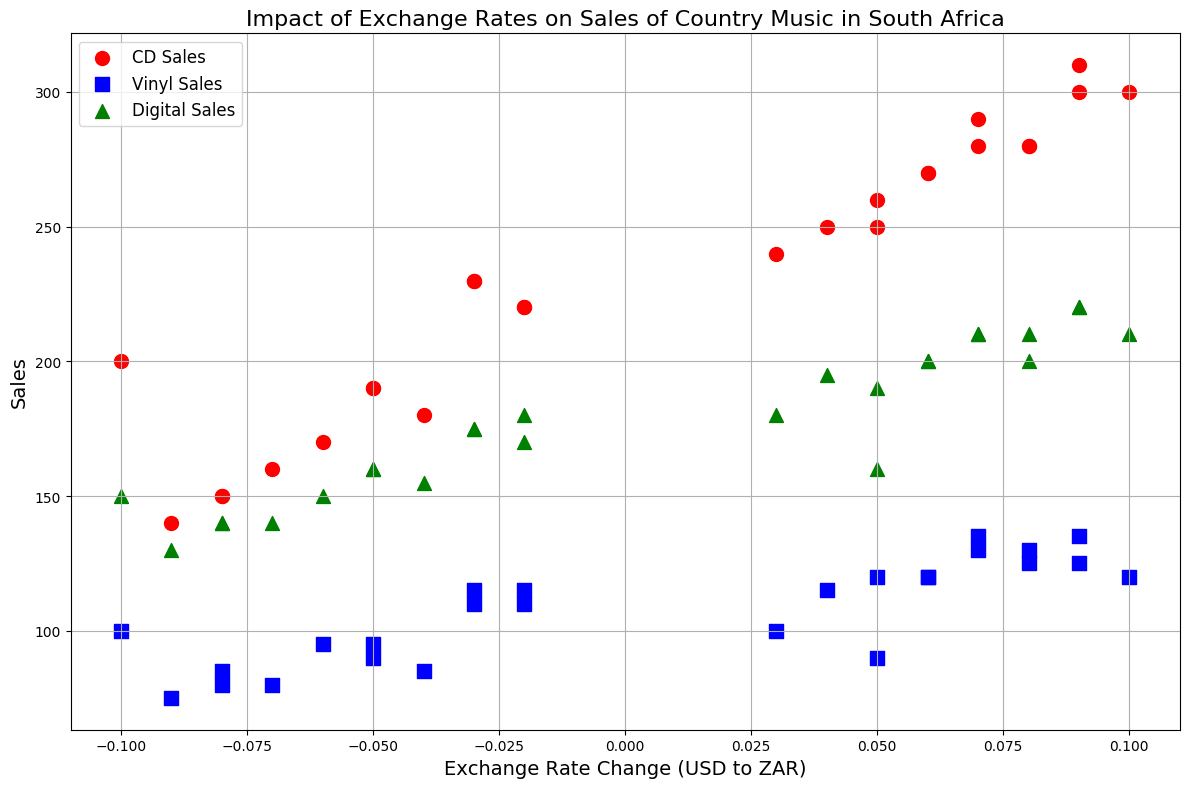What is the overall trend in sales for CDs as the exchange rate changes? Visual inspection shows that as the exchange rate becomes more negative (closer to -0.1), CD sales tend to decrease, and as it becomes more positive, CD sales tend to increase.
Answer: Increasing exchange rate improves CD sales For which month and type of sale did digital downloads reach their highest point? By visually inspecting the scatter plot, the highest point for the green markers (representing digital sales) is seen at an ExchangeRate of 0.09. This corresponds to December 2022.
Answer: December 2022 How does the maximum CD sales compare visually to maximum Vinyl sales? The red markers (CD sales) reach a maximum higher point compared to the blue markers (Vinyl sales). Both reach their maximum at an ExchangeRate of 0.09, but CD sales reach around 310 whereas Vinyl sales reach around 135.
Answer: CD sales are higher Which sales type shows the most sporadic pattern across different exchange rates? By visual inspection, the red markers (CD sales) are more spread out over the axis compared to green (digital) and blue (vinyl) markers.
Answer: CD sales What are the visible colors representing each type of sale? The scatter plot distinguishes sales types using colors: red for CD sales, blue for vinyl sales, and green for digital sales.
Answer: Red, blue, and green Are there any points where the sales of all three types intersect visually? There are no points on the scatter plot where red (CD), blue (vinyl), and green (digital) markers intersect at the same ExchangeRate.
Answer: No How do Sales of Vinyl records vary with exchange rate changes compared to digital downloads? Visually, the blue markers (vinyl sales) do not show as strong a positive trend as the green markers (digital sales) with exchange rate changes. Vinyl sales seem less influenced by exchange rate compared to digital sales.
Answer: Less influenced At what exchange rates are CD sales at their lowest? Red markers (CD sales) are at their lowest points around exchange rates of -0.09 and -0.08.
Answer: -0.09 and -0.08 